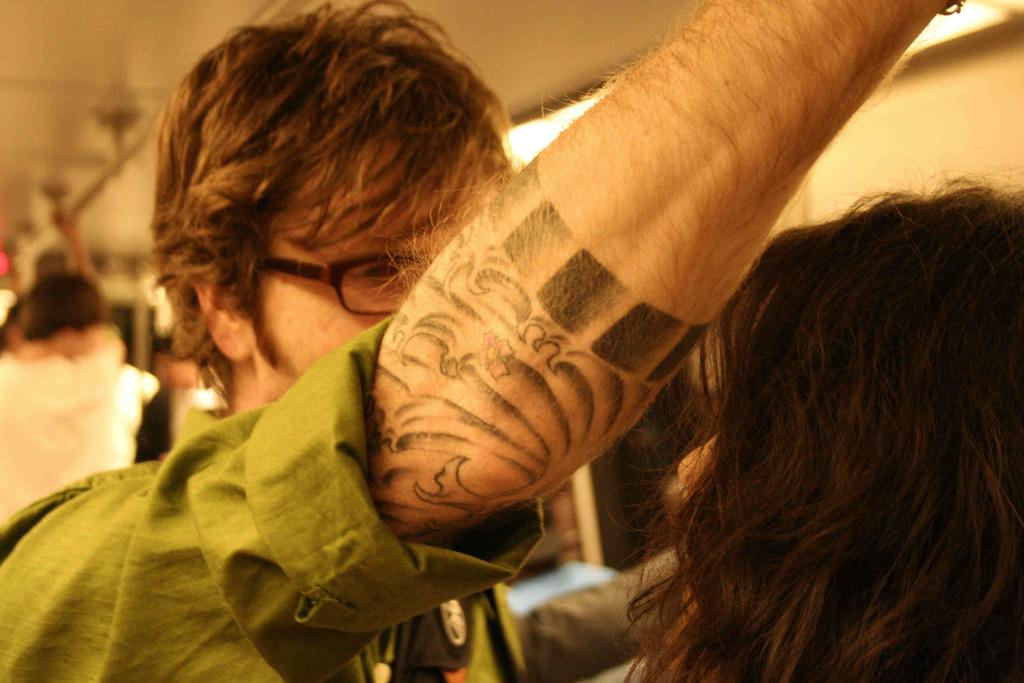How many people are in the image? There are people in the image, but the exact number is not specified. What are the people doing in the image? The people are standing in the image. What objects are the people holding in the image? The people are holding rods in the image. Can you describe the position of the rods in the image? The rods are on the top of something, but the specific object is not mentioned in the transcript. What time of day is it in the image, and how does the wrist of the person holding the rod feel? The time of day is not mentioned in the image, and there is no information about the wrist of the person holding the rod. 